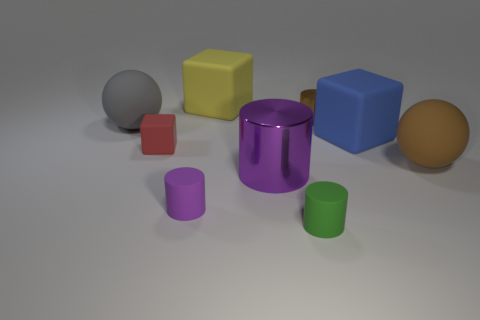Subtract all gray spheres. How many purple cylinders are left? 2 Subtract all big yellow blocks. How many blocks are left? 2 Subtract 2 cylinders. How many cylinders are left? 2 Subtract all green cylinders. How many cylinders are left? 3 Subtract all cyan cylinders. Subtract all gray cubes. How many cylinders are left? 4 Subtract all small purple objects. Subtract all big brown objects. How many objects are left? 7 Add 3 yellow rubber things. How many yellow rubber things are left? 4 Add 6 purple rubber objects. How many purple rubber objects exist? 7 Subtract 0 cyan cylinders. How many objects are left? 9 Subtract all blocks. How many objects are left? 6 